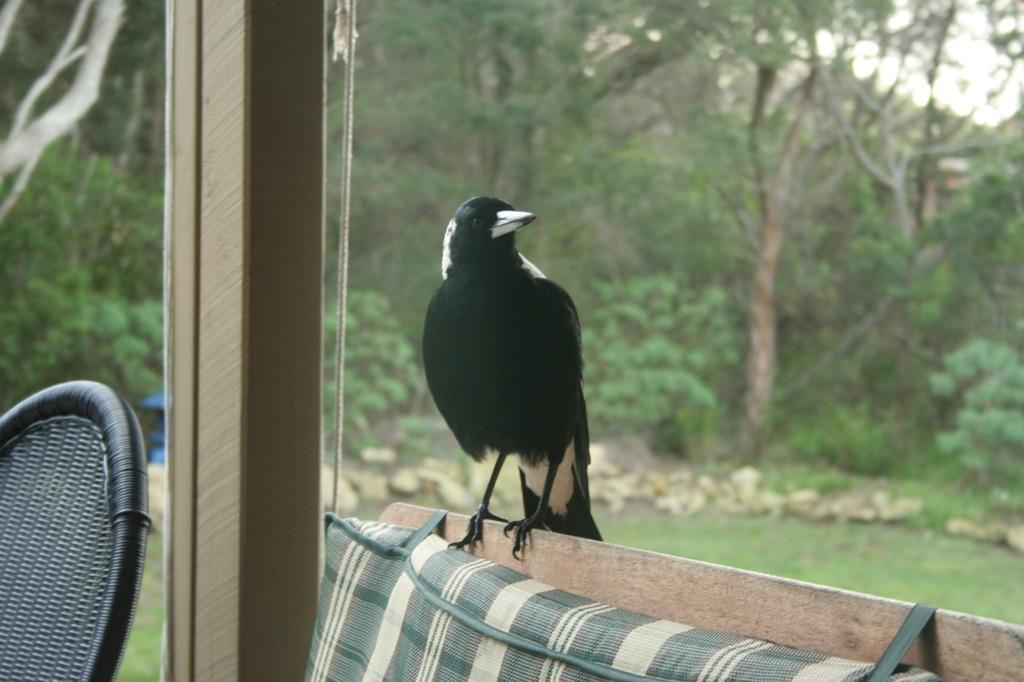What type of seating is visible in the image? There is a chair and a wooden sofa in the image. What is sitting on the wooden sofa? A crow is present on the wooden sofa. What is placed on the wooden sofa? There is a cushion on the wooden sofa. What type of vegetation is visible in the image? Trees are visible in the image. What is the ground covered with in the image? Grass is present on the ground. What type of material is visible in the image? There are stones visible in the image. What is the color of the crow in the image? The crow is black in color. How many minutes does the crow spend on the wooden sofa in the image? The provided facts do not mention the duration of time the crow spends on the wooden sofa, so it cannot be determined from the image. What type of bag is visible in the image? There is no bag present in the image. 